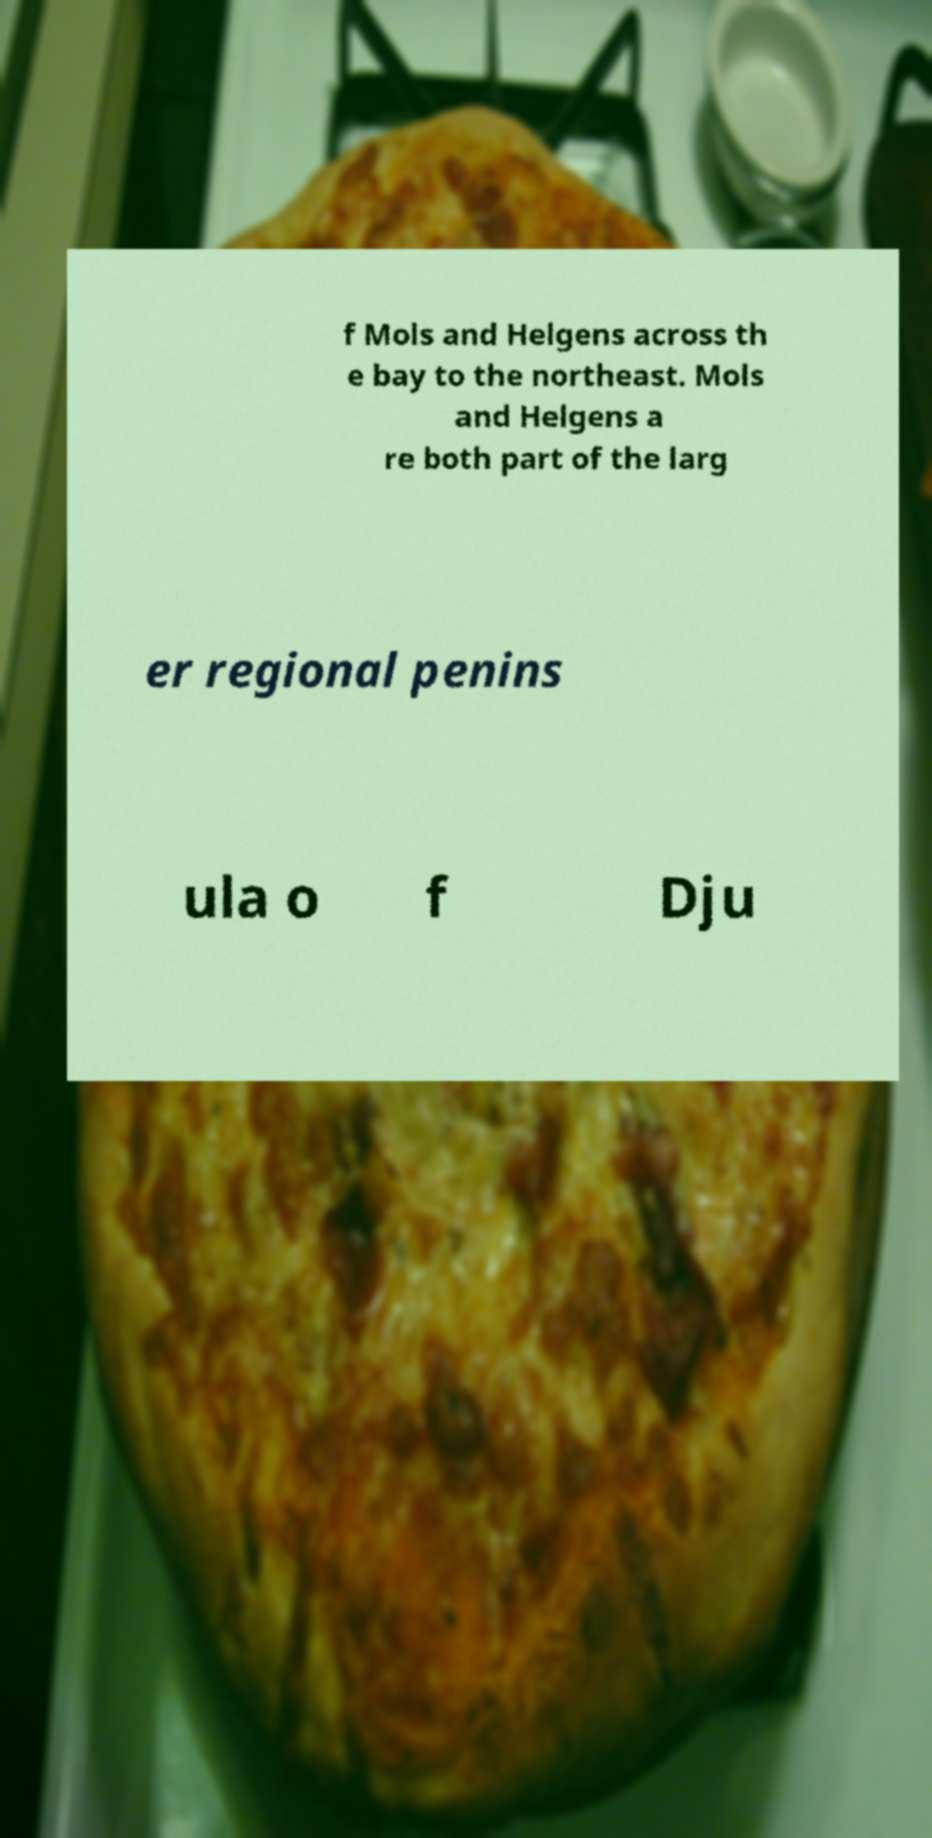Can you accurately transcribe the text from the provided image for me? f Mols and Helgens across th e bay to the northeast. Mols and Helgens a re both part of the larg er regional penins ula o f Dju 